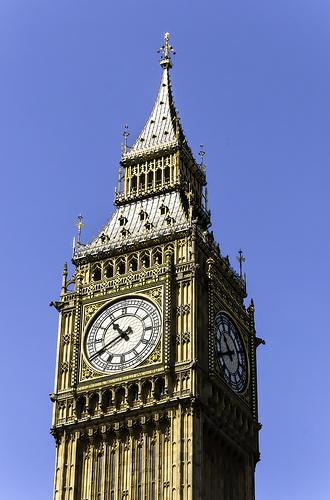What type of sky is shown in this image? Blue cloudless sky Can you detect any part of the clock that helps in reading the time? Hands on the clock and Roman numerals Explain what the main object on this tower is. The main object on the tower is a large round analog clock with clock hands and Roman numerals. What aspect of the image aids in the analysis of detailed architectures? The presence of a tower with ornamental poles, clock face, and Roman numerals provide details for architectural analysis. Identify the most prominent object in this image. A large clock on a tower Explain the overall emotional tone of this image. The image has a calm and peaceful tone with its blue cloudless sky and a tower that tells the time. What element in this image represents an attempt in time calculation? The round analog clocks on the tower with hands and Roman numerals Describe the overall scene in this image. A tower with a large clock, ornamental poles, and Roman numerals against a backdrop of a clear blue sky. What kind of structure is the main focus in this picture? A tall tower with a large clock and ornamental poles How many ornamental poles can you count in the image? There are four ornamental poles on the tower. 